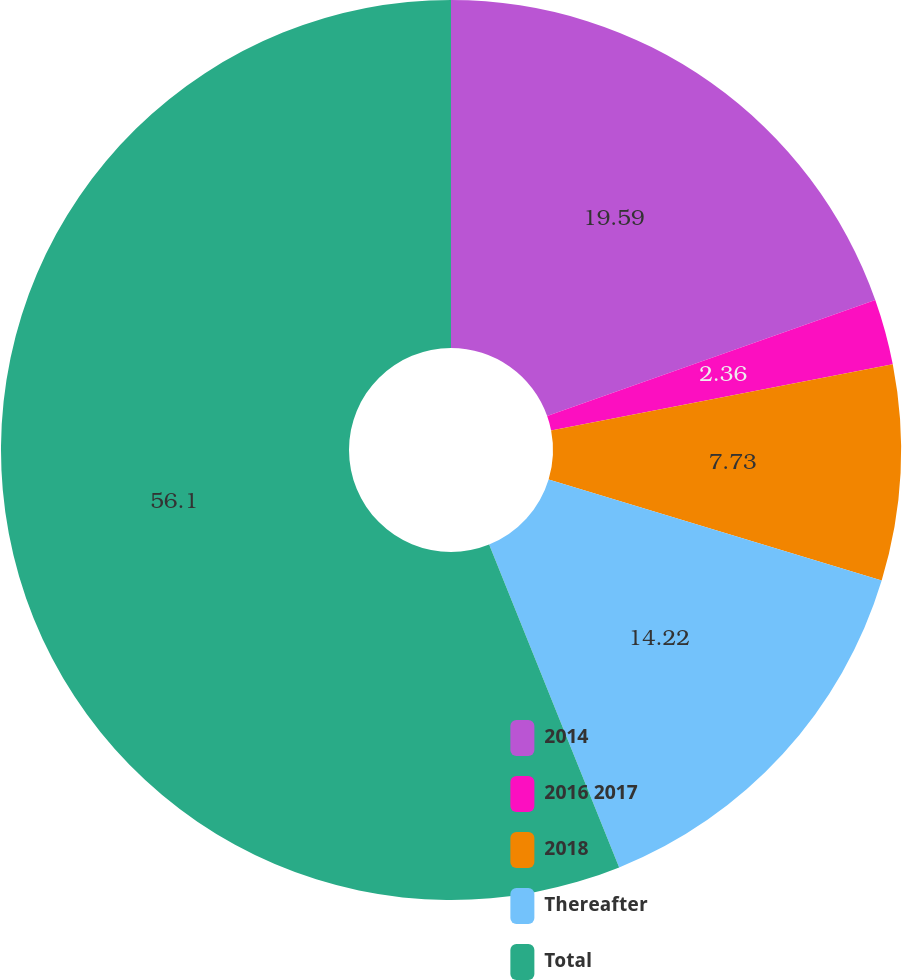Convert chart to OTSL. <chart><loc_0><loc_0><loc_500><loc_500><pie_chart><fcel>2014<fcel>2016 2017<fcel>2018<fcel>Thereafter<fcel>Total<nl><fcel>19.59%<fcel>2.36%<fcel>7.73%<fcel>14.22%<fcel>56.09%<nl></chart> 